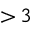<formula> <loc_0><loc_0><loc_500><loc_500>{ > } \, 3</formula> 